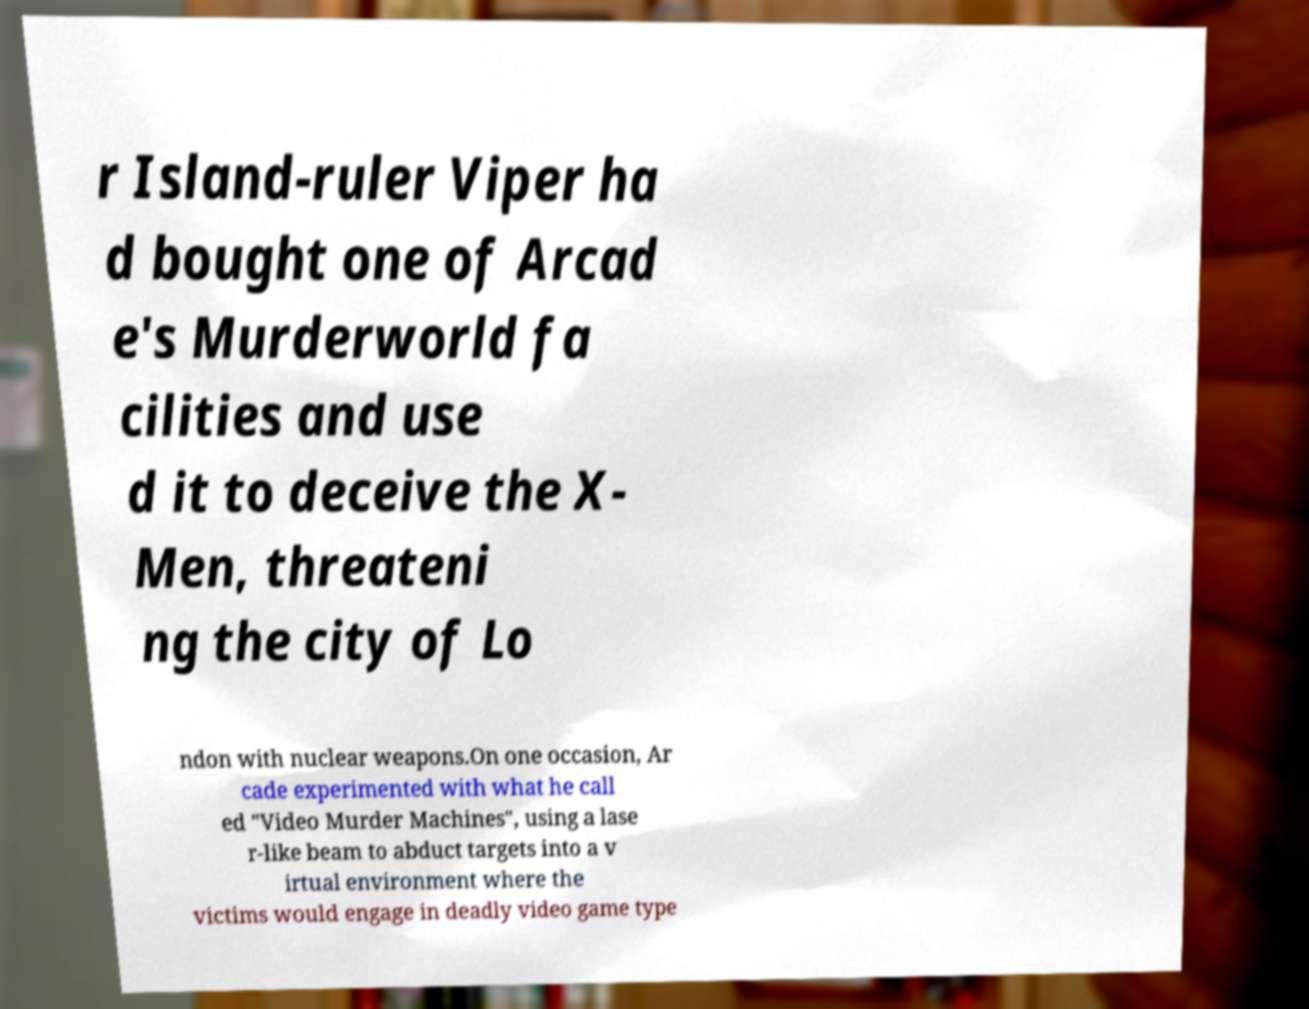Please read and relay the text visible in this image. What does it say? r Island-ruler Viper ha d bought one of Arcad e's Murderworld fa cilities and use d it to deceive the X- Men, threateni ng the city of Lo ndon with nuclear weapons.On one occasion, Ar cade experimented with what he call ed "Video Murder Machines", using a lase r-like beam to abduct targets into a v irtual environment where the victims would engage in deadly video game type 